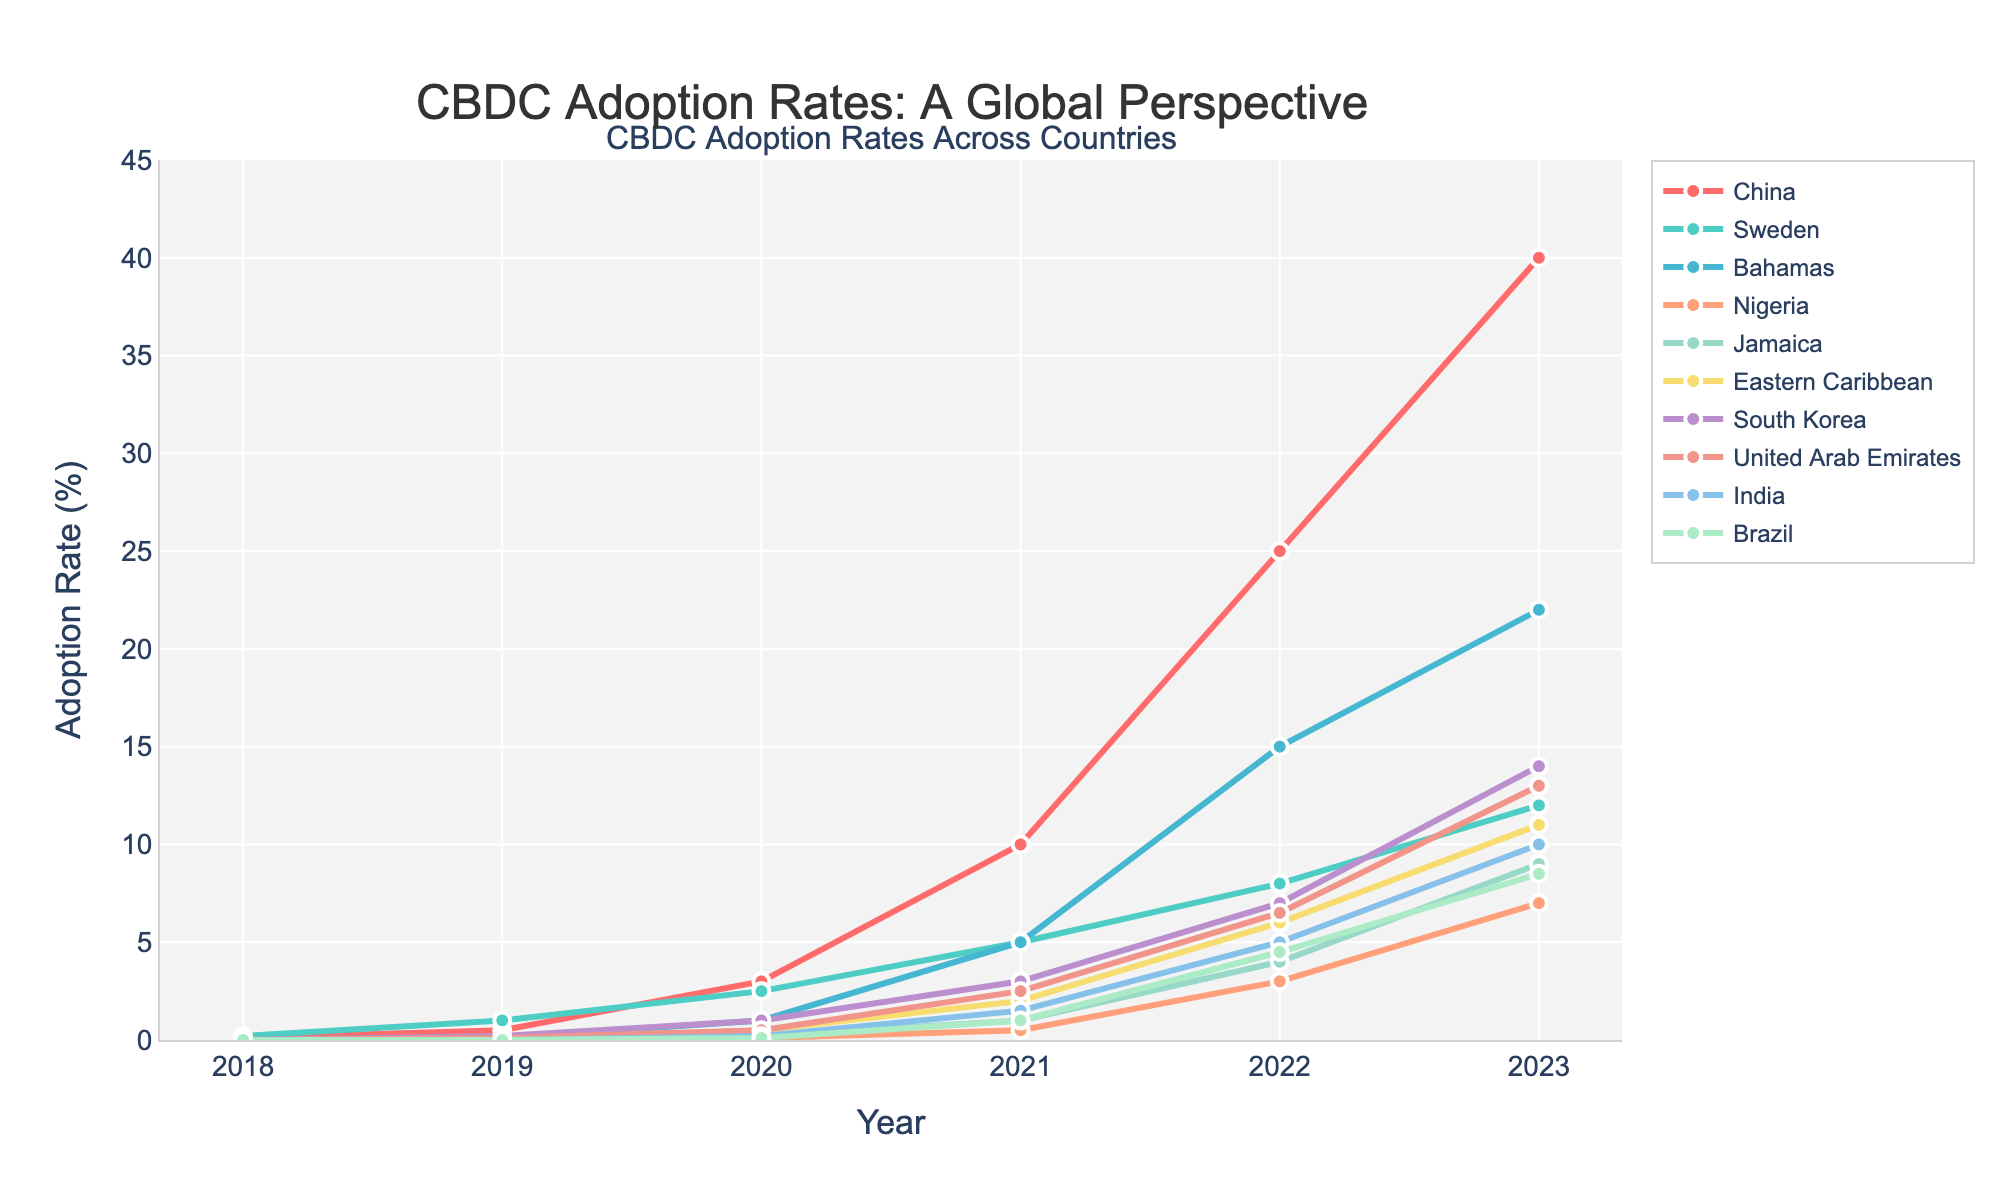What is the adoption rate of CBDCs in China in 2022? The adoption rate in China for 2022 can be directly read from the graph. Look for the point corresponding to China on the year 2022.
Answer: 25.0% Which country had the highest adoption rate of CBDCs in 2023? Compare the adoption rates for all countries in 2023. The highest point on the y-axis corresponding to 2023 is China's.
Answer: China How does the adoption rate of CBDCs in Nigeria in 2023 compare to India in 2023? Find the adoption rates for Nigeria and India in 2023 on the graph. Compare these two values. Nigeria is at 7.0% while India is at 10.0%.
Answer: India has a higher adoption rate than Nigeria Which two countries have the closest adoption rates in 2023, and what are these rates? Examine the adoption rates for all countries in 2023 and look for two countries with the smallest difference. Sweden and United Arab Emirates have rates 12.0% and 13.0% respectively.
Answer: Sweden and UAE, 12.0% and 13.0% By how much did the adoption rate of CBDCs in the Bahamas increase from 2019 to 2023? The adoption rate in the Bahamas was 0.1% in 2019 and increased to 22.0% in 2023. Calculate the difference: 22.0 - 0.1
Answer: 21.9% Which country showed the most significant growth in CBDC adoption from 2021 to 2023? Analyze the slopes of lines between 2021 to 2023. The steeper the slope, the more significant the growth. China has the steepest slope, from 10% in 2021 to 40% in 2023, a growth of 30%.
Answer: China What is the average adoption rate of CBDCs in the Eastern Caribbean for the years provided? Average is calculated by summing the adoption rates over the years and dividing by the number of years: (0 + 0 + 0.5 + 2 + 6 + 11) / 6
Answer: 3.25% How does the adoption rate trend in Brazil compare to South Korea over the time period? Both countries started from 0% adoption in 2018. Brazil shows a steady increase reaching 8.5% in 2023, while South Korea reaches 14.0% in the same period, showing a steeper increase.
Answer: South Korea grows faster What is the difference in adoption rates between the highest and lowest countries in 2022? Find the highest and lowest adoption rates in 2022: China (25%) and Nigeria (3%). Calculate the difference: 25 - 3
Answer: 22% Which country started adopting CBDCs later than others but showed sharp growth later on? Nigeria, Jamaica, Eastern Caribbean, India, and Brazil started with 0% adoption in 2018 but grew significantly later. Compare their trends, and Nigeria showed a notable sharp growth from 2021 (0.5%) to 2023 (7.0%).
Answer: Nigeria 